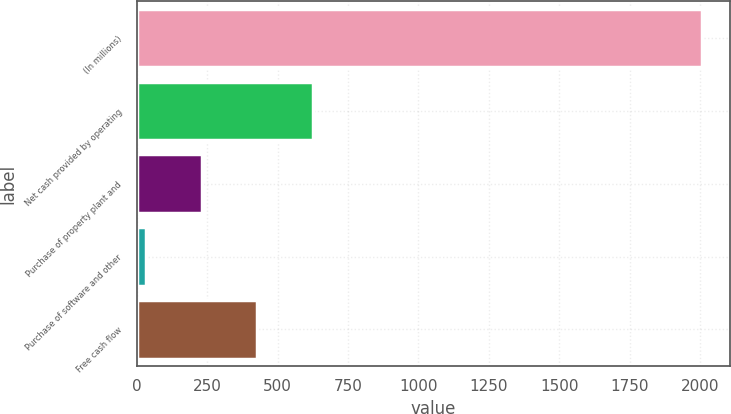Convert chart to OTSL. <chart><loc_0><loc_0><loc_500><loc_500><bar_chart><fcel>(In millions)<fcel>Net cash provided by operating<fcel>Purchase of property plant and<fcel>Purchase of software and other<fcel>Free cash flow<nl><fcel>2006<fcel>625.18<fcel>230.66<fcel>33.4<fcel>427.92<nl></chart> 